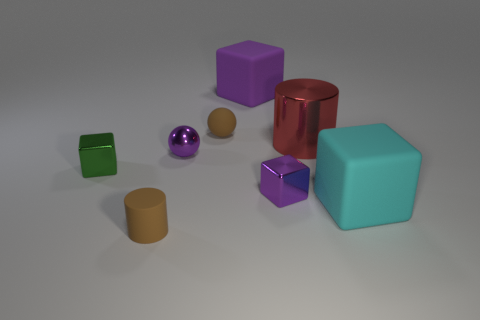Subtract 1 cubes. How many cubes are left? 3 Subtract all red cubes. Subtract all cyan spheres. How many cubes are left? 4 Add 1 tiny red rubber objects. How many objects exist? 9 Subtract all cylinders. How many objects are left? 6 Subtract all small matte balls. Subtract all big blue rubber cylinders. How many objects are left? 7 Add 4 tiny spheres. How many tiny spheres are left? 6 Add 1 small matte objects. How many small matte objects exist? 3 Subtract 1 green cubes. How many objects are left? 7 